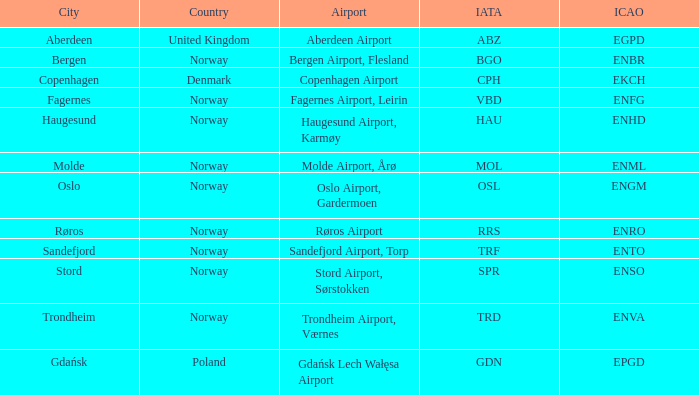What Airport's ICAO is ENTO? Sandefjord Airport, Torp. 